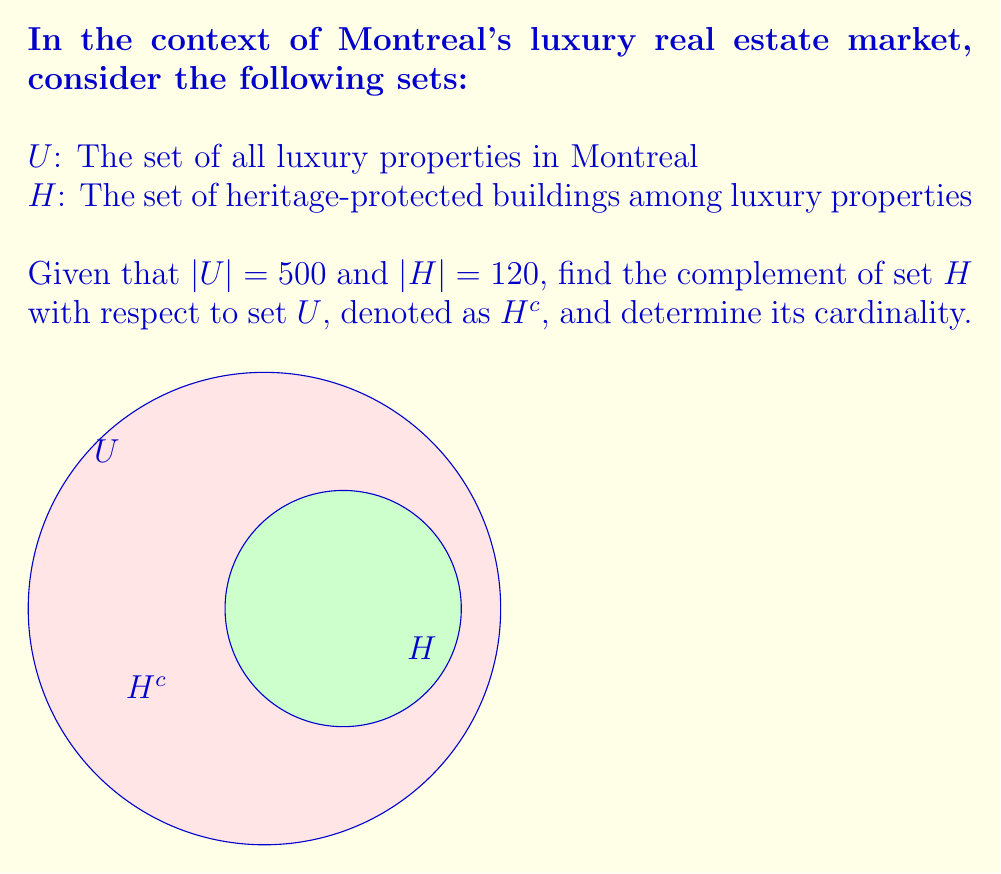Can you answer this question? To solve this problem, we'll follow these steps:

1) First, recall that the complement of a set $H$ with respect to the universal set $U$ is defined as all elements in $U$ that are not in $H$. We denote this as $H^c$.

2) Mathematically, we can express this as:
   $$H^c = U \setminus H$$

3) The cardinality of $H^c$ can be found using the formula:
   $$|H^c| = |U| - |H|$$

4) We are given:
   $|U| = 500$ (total number of luxury properties)
   $|H| = 120$ (number of heritage-protected luxury properties)

5) Substituting these values into our formula:
   $$|H^c| = 500 - 120 = 380$$

6) Therefore, $H^c$ represents all luxury properties in Montreal that are not heritage-protected, and there are 380 such properties.
Answer: $H^c = \{x \in U : x \notin H\}$, $|H^c| = 380$ 